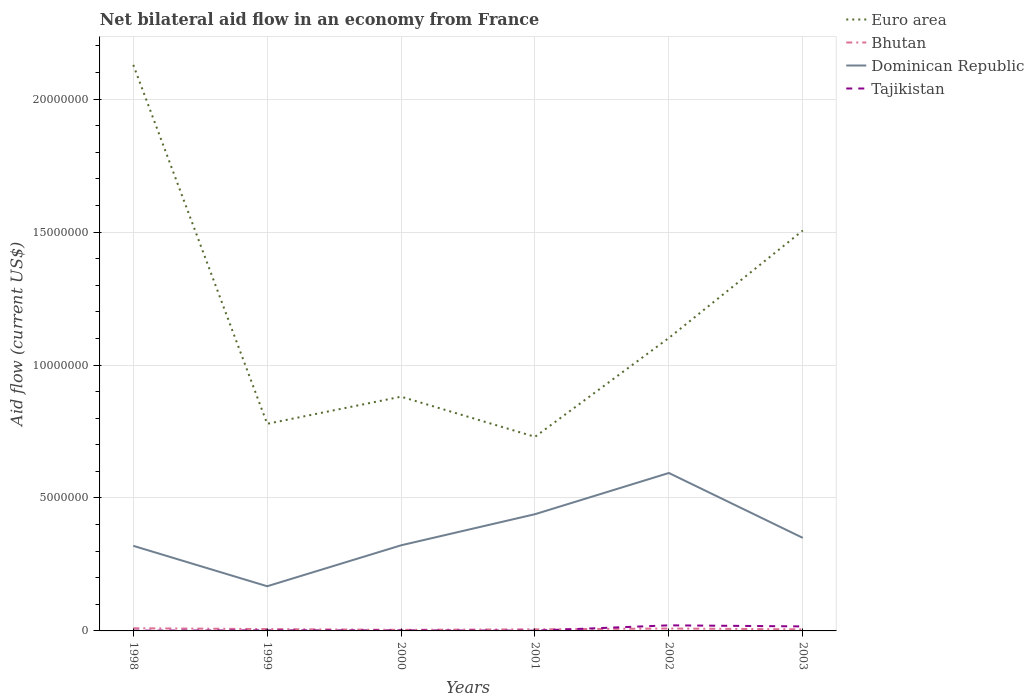How many different coloured lines are there?
Your answer should be very brief. 4. Does the line corresponding to Euro area intersect with the line corresponding to Tajikistan?
Offer a very short reply. No. Is the number of lines equal to the number of legend labels?
Offer a terse response. Yes. Across all years, what is the maximum net bilateral aid flow in Dominican Republic?
Offer a terse response. 1.68e+06. What is the total net bilateral aid flow in Dominican Republic in the graph?
Make the answer very short. -1.17e+06. What is the difference between the highest and the second highest net bilateral aid flow in Euro area?
Make the answer very short. 1.40e+07. How many lines are there?
Make the answer very short. 4. How many years are there in the graph?
Your answer should be very brief. 6. Are the values on the major ticks of Y-axis written in scientific E-notation?
Offer a terse response. No. What is the title of the graph?
Offer a terse response. Net bilateral aid flow in an economy from France. What is the label or title of the Y-axis?
Make the answer very short. Aid flow (current US$). What is the Aid flow (current US$) of Euro area in 1998?
Make the answer very short. 2.13e+07. What is the Aid flow (current US$) in Bhutan in 1998?
Make the answer very short. 1.00e+05. What is the Aid flow (current US$) in Dominican Republic in 1998?
Ensure brevity in your answer.  3.20e+06. What is the Aid flow (current US$) of Tajikistan in 1998?
Keep it short and to the point. 10000. What is the Aid flow (current US$) in Euro area in 1999?
Provide a succinct answer. 7.79e+06. What is the Aid flow (current US$) in Dominican Republic in 1999?
Provide a short and direct response. 1.68e+06. What is the Aid flow (current US$) in Tajikistan in 1999?
Make the answer very short. 2.00e+04. What is the Aid flow (current US$) of Euro area in 2000?
Your response must be concise. 8.81e+06. What is the Aid flow (current US$) of Bhutan in 2000?
Give a very brief answer. 4.00e+04. What is the Aid flow (current US$) in Dominican Republic in 2000?
Your response must be concise. 3.22e+06. What is the Aid flow (current US$) of Tajikistan in 2000?
Offer a very short reply. 2.00e+04. What is the Aid flow (current US$) of Euro area in 2001?
Keep it short and to the point. 7.30e+06. What is the Aid flow (current US$) of Dominican Republic in 2001?
Offer a terse response. 4.39e+06. What is the Aid flow (current US$) of Euro area in 2002?
Your answer should be compact. 1.10e+07. What is the Aid flow (current US$) of Bhutan in 2002?
Provide a succinct answer. 9.00e+04. What is the Aid flow (current US$) of Dominican Republic in 2002?
Your response must be concise. 5.94e+06. What is the Aid flow (current US$) in Euro area in 2003?
Give a very brief answer. 1.51e+07. What is the Aid flow (current US$) in Bhutan in 2003?
Make the answer very short. 6.00e+04. What is the Aid flow (current US$) in Dominican Republic in 2003?
Your answer should be very brief. 3.50e+06. Across all years, what is the maximum Aid flow (current US$) of Euro area?
Give a very brief answer. 2.13e+07. Across all years, what is the maximum Aid flow (current US$) in Bhutan?
Ensure brevity in your answer.  1.00e+05. Across all years, what is the maximum Aid flow (current US$) of Dominican Republic?
Offer a very short reply. 5.94e+06. Across all years, what is the maximum Aid flow (current US$) of Tajikistan?
Offer a very short reply. 2.10e+05. Across all years, what is the minimum Aid flow (current US$) of Euro area?
Provide a short and direct response. 7.30e+06. Across all years, what is the minimum Aid flow (current US$) of Dominican Republic?
Offer a very short reply. 1.68e+06. Across all years, what is the minimum Aid flow (current US$) of Tajikistan?
Provide a succinct answer. 10000. What is the total Aid flow (current US$) in Euro area in the graph?
Keep it short and to the point. 7.13e+07. What is the total Aid flow (current US$) in Bhutan in the graph?
Give a very brief answer. 4.20e+05. What is the total Aid flow (current US$) of Dominican Republic in the graph?
Offer a very short reply. 2.19e+07. What is the total Aid flow (current US$) of Tajikistan in the graph?
Provide a short and direct response. 4.40e+05. What is the difference between the Aid flow (current US$) in Euro area in 1998 and that in 1999?
Ensure brevity in your answer.  1.35e+07. What is the difference between the Aid flow (current US$) of Bhutan in 1998 and that in 1999?
Offer a very short reply. 3.00e+04. What is the difference between the Aid flow (current US$) of Dominican Republic in 1998 and that in 1999?
Your response must be concise. 1.52e+06. What is the difference between the Aid flow (current US$) in Euro area in 1998 and that in 2000?
Provide a short and direct response. 1.25e+07. What is the difference between the Aid flow (current US$) of Tajikistan in 1998 and that in 2000?
Your answer should be very brief. -10000. What is the difference between the Aid flow (current US$) in Euro area in 1998 and that in 2001?
Give a very brief answer. 1.40e+07. What is the difference between the Aid flow (current US$) in Dominican Republic in 1998 and that in 2001?
Your answer should be compact. -1.19e+06. What is the difference between the Aid flow (current US$) of Euro area in 1998 and that in 2002?
Provide a short and direct response. 1.03e+07. What is the difference between the Aid flow (current US$) in Dominican Republic in 1998 and that in 2002?
Keep it short and to the point. -2.74e+06. What is the difference between the Aid flow (current US$) of Euro area in 1998 and that in 2003?
Keep it short and to the point. 6.23e+06. What is the difference between the Aid flow (current US$) of Bhutan in 1998 and that in 2003?
Provide a succinct answer. 4.00e+04. What is the difference between the Aid flow (current US$) of Euro area in 1999 and that in 2000?
Provide a short and direct response. -1.02e+06. What is the difference between the Aid flow (current US$) of Dominican Republic in 1999 and that in 2000?
Keep it short and to the point. -1.54e+06. What is the difference between the Aid flow (current US$) in Bhutan in 1999 and that in 2001?
Offer a terse response. 10000. What is the difference between the Aid flow (current US$) of Dominican Republic in 1999 and that in 2001?
Offer a very short reply. -2.71e+06. What is the difference between the Aid flow (current US$) in Euro area in 1999 and that in 2002?
Provide a succinct answer. -3.23e+06. What is the difference between the Aid flow (current US$) of Bhutan in 1999 and that in 2002?
Your answer should be compact. -2.00e+04. What is the difference between the Aid flow (current US$) of Dominican Republic in 1999 and that in 2002?
Your answer should be very brief. -4.26e+06. What is the difference between the Aid flow (current US$) of Tajikistan in 1999 and that in 2002?
Your answer should be very brief. -1.90e+05. What is the difference between the Aid flow (current US$) of Euro area in 1999 and that in 2003?
Make the answer very short. -7.27e+06. What is the difference between the Aid flow (current US$) in Dominican Republic in 1999 and that in 2003?
Your answer should be compact. -1.82e+06. What is the difference between the Aid flow (current US$) of Tajikistan in 1999 and that in 2003?
Offer a terse response. -1.50e+05. What is the difference between the Aid flow (current US$) in Euro area in 2000 and that in 2001?
Give a very brief answer. 1.51e+06. What is the difference between the Aid flow (current US$) of Dominican Republic in 2000 and that in 2001?
Offer a very short reply. -1.17e+06. What is the difference between the Aid flow (current US$) of Euro area in 2000 and that in 2002?
Make the answer very short. -2.21e+06. What is the difference between the Aid flow (current US$) in Bhutan in 2000 and that in 2002?
Ensure brevity in your answer.  -5.00e+04. What is the difference between the Aid flow (current US$) in Dominican Republic in 2000 and that in 2002?
Keep it short and to the point. -2.72e+06. What is the difference between the Aid flow (current US$) of Euro area in 2000 and that in 2003?
Provide a succinct answer. -6.25e+06. What is the difference between the Aid flow (current US$) of Dominican Republic in 2000 and that in 2003?
Keep it short and to the point. -2.80e+05. What is the difference between the Aid flow (current US$) in Euro area in 2001 and that in 2002?
Your response must be concise. -3.72e+06. What is the difference between the Aid flow (current US$) in Bhutan in 2001 and that in 2002?
Make the answer very short. -3.00e+04. What is the difference between the Aid flow (current US$) of Dominican Republic in 2001 and that in 2002?
Ensure brevity in your answer.  -1.55e+06. What is the difference between the Aid flow (current US$) in Tajikistan in 2001 and that in 2002?
Make the answer very short. -2.00e+05. What is the difference between the Aid flow (current US$) in Euro area in 2001 and that in 2003?
Offer a terse response. -7.76e+06. What is the difference between the Aid flow (current US$) in Dominican Republic in 2001 and that in 2003?
Give a very brief answer. 8.90e+05. What is the difference between the Aid flow (current US$) of Tajikistan in 2001 and that in 2003?
Your answer should be compact. -1.60e+05. What is the difference between the Aid flow (current US$) in Euro area in 2002 and that in 2003?
Ensure brevity in your answer.  -4.04e+06. What is the difference between the Aid flow (current US$) of Bhutan in 2002 and that in 2003?
Keep it short and to the point. 3.00e+04. What is the difference between the Aid flow (current US$) in Dominican Republic in 2002 and that in 2003?
Your answer should be compact. 2.44e+06. What is the difference between the Aid flow (current US$) of Tajikistan in 2002 and that in 2003?
Give a very brief answer. 4.00e+04. What is the difference between the Aid flow (current US$) of Euro area in 1998 and the Aid flow (current US$) of Bhutan in 1999?
Ensure brevity in your answer.  2.12e+07. What is the difference between the Aid flow (current US$) of Euro area in 1998 and the Aid flow (current US$) of Dominican Republic in 1999?
Provide a short and direct response. 1.96e+07. What is the difference between the Aid flow (current US$) in Euro area in 1998 and the Aid flow (current US$) in Tajikistan in 1999?
Provide a succinct answer. 2.13e+07. What is the difference between the Aid flow (current US$) of Bhutan in 1998 and the Aid flow (current US$) of Dominican Republic in 1999?
Your answer should be very brief. -1.58e+06. What is the difference between the Aid flow (current US$) in Dominican Republic in 1998 and the Aid flow (current US$) in Tajikistan in 1999?
Your response must be concise. 3.18e+06. What is the difference between the Aid flow (current US$) of Euro area in 1998 and the Aid flow (current US$) of Bhutan in 2000?
Ensure brevity in your answer.  2.12e+07. What is the difference between the Aid flow (current US$) in Euro area in 1998 and the Aid flow (current US$) in Dominican Republic in 2000?
Your response must be concise. 1.81e+07. What is the difference between the Aid flow (current US$) of Euro area in 1998 and the Aid flow (current US$) of Tajikistan in 2000?
Offer a very short reply. 2.13e+07. What is the difference between the Aid flow (current US$) of Bhutan in 1998 and the Aid flow (current US$) of Dominican Republic in 2000?
Your answer should be compact. -3.12e+06. What is the difference between the Aid flow (current US$) of Dominican Republic in 1998 and the Aid flow (current US$) of Tajikistan in 2000?
Provide a succinct answer. 3.18e+06. What is the difference between the Aid flow (current US$) in Euro area in 1998 and the Aid flow (current US$) in Bhutan in 2001?
Keep it short and to the point. 2.12e+07. What is the difference between the Aid flow (current US$) in Euro area in 1998 and the Aid flow (current US$) in Dominican Republic in 2001?
Your answer should be very brief. 1.69e+07. What is the difference between the Aid flow (current US$) of Euro area in 1998 and the Aid flow (current US$) of Tajikistan in 2001?
Ensure brevity in your answer.  2.13e+07. What is the difference between the Aid flow (current US$) of Bhutan in 1998 and the Aid flow (current US$) of Dominican Republic in 2001?
Your response must be concise. -4.29e+06. What is the difference between the Aid flow (current US$) of Bhutan in 1998 and the Aid flow (current US$) of Tajikistan in 2001?
Your answer should be very brief. 9.00e+04. What is the difference between the Aid flow (current US$) of Dominican Republic in 1998 and the Aid flow (current US$) of Tajikistan in 2001?
Keep it short and to the point. 3.19e+06. What is the difference between the Aid flow (current US$) of Euro area in 1998 and the Aid flow (current US$) of Bhutan in 2002?
Your response must be concise. 2.12e+07. What is the difference between the Aid flow (current US$) of Euro area in 1998 and the Aid flow (current US$) of Dominican Republic in 2002?
Keep it short and to the point. 1.54e+07. What is the difference between the Aid flow (current US$) in Euro area in 1998 and the Aid flow (current US$) in Tajikistan in 2002?
Your response must be concise. 2.11e+07. What is the difference between the Aid flow (current US$) in Bhutan in 1998 and the Aid flow (current US$) in Dominican Republic in 2002?
Your answer should be very brief. -5.84e+06. What is the difference between the Aid flow (current US$) of Bhutan in 1998 and the Aid flow (current US$) of Tajikistan in 2002?
Offer a very short reply. -1.10e+05. What is the difference between the Aid flow (current US$) of Dominican Republic in 1998 and the Aid flow (current US$) of Tajikistan in 2002?
Make the answer very short. 2.99e+06. What is the difference between the Aid flow (current US$) of Euro area in 1998 and the Aid flow (current US$) of Bhutan in 2003?
Offer a terse response. 2.12e+07. What is the difference between the Aid flow (current US$) of Euro area in 1998 and the Aid flow (current US$) of Dominican Republic in 2003?
Your response must be concise. 1.78e+07. What is the difference between the Aid flow (current US$) of Euro area in 1998 and the Aid flow (current US$) of Tajikistan in 2003?
Your response must be concise. 2.11e+07. What is the difference between the Aid flow (current US$) in Bhutan in 1998 and the Aid flow (current US$) in Dominican Republic in 2003?
Make the answer very short. -3.40e+06. What is the difference between the Aid flow (current US$) in Bhutan in 1998 and the Aid flow (current US$) in Tajikistan in 2003?
Give a very brief answer. -7.00e+04. What is the difference between the Aid flow (current US$) of Dominican Republic in 1998 and the Aid flow (current US$) of Tajikistan in 2003?
Your answer should be compact. 3.03e+06. What is the difference between the Aid flow (current US$) in Euro area in 1999 and the Aid flow (current US$) in Bhutan in 2000?
Offer a terse response. 7.75e+06. What is the difference between the Aid flow (current US$) of Euro area in 1999 and the Aid flow (current US$) of Dominican Republic in 2000?
Provide a short and direct response. 4.57e+06. What is the difference between the Aid flow (current US$) of Euro area in 1999 and the Aid flow (current US$) of Tajikistan in 2000?
Your answer should be very brief. 7.77e+06. What is the difference between the Aid flow (current US$) of Bhutan in 1999 and the Aid flow (current US$) of Dominican Republic in 2000?
Offer a terse response. -3.15e+06. What is the difference between the Aid flow (current US$) of Dominican Republic in 1999 and the Aid flow (current US$) of Tajikistan in 2000?
Your answer should be compact. 1.66e+06. What is the difference between the Aid flow (current US$) in Euro area in 1999 and the Aid flow (current US$) in Bhutan in 2001?
Provide a succinct answer. 7.73e+06. What is the difference between the Aid flow (current US$) in Euro area in 1999 and the Aid flow (current US$) in Dominican Republic in 2001?
Make the answer very short. 3.40e+06. What is the difference between the Aid flow (current US$) in Euro area in 1999 and the Aid flow (current US$) in Tajikistan in 2001?
Your answer should be very brief. 7.78e+06. What is the difference between the Aid flow (current US$) of Bhutan in 1999 and the Aid flow (current US$) of Dominican Republic in 2001?
Your response must be concise. -4.32e+06. What is the difference between the Aid flow (current US$) of Bhutan in 1999 and the Aid flow (current US$) of Tajikistan in 2001?
Ensure brevity in your answer.  6.00e+04. What is the difference between the Aid flow (current US$) of Dominican Republic in 1999 and the Aid flow (current US$) of Tajikistan in 2001?
Keep it short and to the point. 1.67e+06. What is the difference between the Aid flow (current US$) of Euro area in 1999 and the Aid flow (current US$) of Bhutan in 2002?
Your response must be concise. 7.70e+06. What is the difference between the Aid flow (current US$) in Euro area in 1999 and the Aid flow (current US$) in Dominican Republic in 2002?
Provide a short and direct response. 1.85e+06. What is the difference between the Aid flow (current US$) of Euro area in 1999 and the Aid flow (current US$) of Tajikistan in 2002?
Provide a short and direct response. 7.58e+06. What is the difference between the Aid flow (current US$) of Bhutan in 1999 and the Aid flow (current US$) of Dominican Republic in 2002?
Offer a very short reply. -5.87e+06. What is the difference between the Aid flow (current US$) in Bhutan in 1999 and the Aid flow (current US$) in Tajikistan in 2002?
Provide a succinct answer. -1.40e+05. What is the difference between the Aid flow (current US$) of Dominican Republic in 1999 and the Aid flow (current US$) of Tajikistan in 2002?
Offer a terse response. 1.47e+06. What is the difference between the Aid flow (current US$) of Euro area in 1999 and the Aid flow (current US$) of Bhutan in 2003?
Ensure brevity in your answer.  7.73e+06. What is the difference between the Aid flow (current US$) in Euro area in 1999 and the Aid flow (current US$) in Dominican Republic in 2003?
Make the answer very short. 4.29e+06. What is the difference between the Aid flow (current US$) in Euro area in 1999 and the Aid flow (current US$) in Tajikistan in 2003?
Make the answer very short. 7.62e+06. What is the difference between the Aid flow (current US$) of Bhutan in 1999 and the Aid flow (current US$) of Dominican Republic in 2003?
Give a very brief answer. -3.43e+06. What is the difference between the Aid flow (current US$) in Bhutan in 1999 and the Aid flow (current US$) in Tajikistan in 2003?
Your answer should be very brief. -1.00e+05. What is the difference between the Aid flow (current US$) in Dominican Republic in 1999 and the Aid flow (current US$) in Tajikistan in 2003?
Ensure brevity in your answer.  1.51e+06. What is the difference between the Aid flow (current US$) of Euro area in 2000 and the Aid flow (current US$) of Bhutan in 2001?
Provide a succinct answer. 8.75e+06. What is the difference between the Aid flow (current US$) of Euro area in 2000 and the Aid flow (current US$) of Dominican Republic in 2001?
Provide a short and direct response. 4.42e+06. What is the difference between the Aid flow (current US$) of Euro area in 2000 and the Aid flow (current US$) of Tajikistan in 2001?
Your answer should be compact. 8.80e+06. What is the difference between the Aid flow (current US$) in Bhutan in 2000 and the Aid flow (current US$) in Dominican Republic in 2001?
Your answer should be very brief. -4.35e+06. What is the difference between the Aid flow (current US$) of Bhutan in 2000 and the Aid flow (current US$) of Tajikistan in 2001?
Keep it short and to the point. 3.00e+04. What is the difference between the Aid flow (current US$) of Dominican Republic in 2000 and the Aid flow (current US$) of Tajikistan in 2001?
Give a very brief answer. 3.21e+06. What is the difference between the Aid flow (current US$) of Euro area in 2000 and the Aid flow (current US$) of Bhutan in 2002?
Your answer should be compact. 8.72e+06. What is the difference between the Aid flow (current US$) in Euro area in 2000 and the Aid flow (current US$) in Dominican Republic in 2002?
Keep it short and to the point. 2.87e+06. What is the difference between the Aid flow (current US$) of Euro area in 2000 and the Aid flow (current US$) of Tajikistan in 2002?
Provide a succinct answer. 8.60e+06. What is the difference between the Aid flow (current US$) of Bhutan in 2000 and the Aid flow (current US$) of Dominican Republic in 2002?
Keep it short and to the point. -5.90e+06. What is the difference between the Aid flow (current US$) of Bhutan in 2000 and the Aid flow (current US$) of Tajikistan in 2002?
Provide a succinct answer. -1.70e+05. What is the difference between the Aid flow (current US$) of Dominican Republic in 2000 and the Aid flow (current US$) of Tajikistan in 2002?
Your answer should be very brief. 3.01e+06. What is the difference between the Aid flow (current US$) in Euro area in 2000 and the Aid flow (current US$) in Bhutan in 2003?
Provide a short and direct response. 8.75e+06. What is the difference between the Aid flow (current US$) of Euro area in 2000 and the Aid flow (current US$) of Dominican Republic in 2003?
Make the answer very short. 5.31e+06. What is the difference between the Aid flow (current US$) in Euro area in 2000 and the Aid flow (current US$) in Tajikistan in 2003?
Offer a very short reply. 8.64e+06. What is the difference between the Aid flow (current US$) of Bhutan in 2000 and the Aid flow (current US$) of Dominican Republic in 2003?
Make the answer very short. -3.46e+06. What is the difference between the Aid flow (current US$) in Bhutan in 2000 and the Aid flow (current US$) in Tajikistan in 2003?
Keep it short and to the point. -1.30e+05. What is the difference between the Aid flow (current US$) of Dominican Republic in 2000 and the Aid flow (current US$) of Tajikistan in 2003?
Your answer should be compact. 3.05e+06. What is the difference between the Aid flow (current US$) in Euro area in 2001 and the Aid flow (current US$) in Bhutan in 2002?
Keep it short and to the point. 7.21e+06. What is the difference between the Aid flow (current US$) of Euro area in 2001 and the Aid flow (current US$) of Dominican Republic in 2002?
Your response must be concise. 1.36e+06. What is the difference between the Aid flow (current US$) in Euro area in 2001 and the Aid flow (current US$) in Tajikistan in 2002?
Your answer should be compact. 7.09e+06. What is the difference between the Aid flow (current US$) of Bhutan in 2001 and the Aid flow (current US$) of Dominican Republic in 2002?
Give a very brief answer. -5.88e+06. What is the difference between the Aid flow (current US$) of Dominican Republic in 2001 and the Aid flow (current US$) of Tajikistan in 2002?
Offer a very short reply. 4.18e+06. What is the difference between the Aid flow (current US$) in Euro area in 2001 and the Aid flow (current US$) in Bhutan in 2003?
Provide a short and direct response. 7.24e+06. What is the difference between the Aid flow (current US$) in Euro area in 2001 and the Aid flow (current US$) in Dominican Republic in 2003?
Your answer should be very brief. 3.80e+06. What is the difference between the Aid flow (current US$) of Euro area in 2001 and the Aid flow (current US$) of Tajikistan in 2003?
Ensure brevity in your answer.  7.13e+06. What is the difference between the Aid flow (current US$) in Bhutan in 2001 and the Aid flow (current US$) in Dominican Republic in 2003?
Keep it short and to the point. -3.44e+06. What is the difference between the Aid flow (current US$) in Bhutan in 2001 and the Aid flow (current US$) in Tajikistan in 2003?
Give a very brief answer. -1.10e+05. What is the difference between the Aid flow (current US$) in Dominican Republic in 2001 and the Aid flow (current US$) in Tajikistan in 2003?
Make the answer very short. 4.22e+06. What is the difference between the Aid flow (current US$) of Euro area in 2002 and the Aid flow (current US$) of Bhutan in 2003?
Your answer should be compact. 1.10e+07. What is the difference between the Aid flow (current US$) of Euro area in 2002 and the Aid flow (current US$) of Dominican Republic in 2003?
Ensure brevity in your answer.  7.52e+06. What is the difference between the Aid flow (current US$) of Euro area in 2002 and the Aid flow (current US$) of Tajikistan in 2003?
Provide a short and direct response. 1.08e+07. What is the difference between the Aid flow (current US$) of Bhutan in 2002 and the Aid flow (current US$) of Dominican Republic in 2003?
Your response must be concise. -3.41e+06. What is the difference between the Aid flow (current US$) of Bhutan in 2002 and the Aid flow (current US$) of Tajikistan in 2003?
Keep it short and to the point. -8.00e+04. What is the difference between the Aid flow (current US$) in Dominican Republic in 2002 and the Aid flow (current US$) in Tajikistan in 2003?
Offer a very short reply. 5.77e+06. What is the average Aid flow (current US$) of Euro area per year?
Make the answer very short. 1.19e+07. What is the average Aid flow (current US$) in Dominican Republic per year?
Make the answer very short. 3.66e+06. What is the average Aid flow (current US$) in Tajikistan per year?
Keep it short and to the point. 7.33e+04. In the year 1998, what is the difference between the Aid flow (current US$) in Euro area and Aid flow (current US$) in Bhutan?
Provide a succinct answer. 2.12e+07. In the year 1998, what is the difference between the Aid flow (current US$) in Euro area and Aid flow (current US$) in Dominican Republic?
Your answer should be very brief. 1.81e+07. In the year 1998, what is the difference between the Aid flow (current US$) of Euro area and Aid flow (current US$) of Tajikistan?
Offer a very short reply. 2.13e+07. In the year 1998, what is the difference between the Aid flow (current US$) in Bhutan and Aid flow (current US$) in Dominican Republic?
Keep it short and to the point. -3.10e+06. In the year 1998, what is the difference between the Aid flow (current US$) in Dominican Republic and Aid flow (current US$) in Tajikistan?
Make the answer very short. 3.19e+06. In the year 1999, what is the difference between the Aid flow (current US$) in Euro area and Aid flow (current US$) in Bhutan?
Offer a very short reply. 7.72e+06. In the year 1999, what is the difference between the Aid flow (current US$) in Euro area and Aid flow (current US$) in Dominican Republic?
Make the answer very short. 6.11e+06. In the year 1999, what is the difference between the Aid flow (current US$) of Euro area and Aid flow (current US$) of Tajikistan?
Make the answer very short. 7.77e+06. In the year 1999, what is the difference between the Aid flow (current US$) in Bhutan and Aid flow (current US$) in Dominican Republic?
Make the answer very short. -1.61e+06. In the year 1999, what is the difference between the Aid flow (current US$) of Dominican Republic and Aid flow (current US$) of Tajikistan?
Provide a short and direct response. 1.66e+06. In the year 2000, what is the difference between the Aid flow (current US$) in Euro area and Aid flow (current US$) in Bhutan?
Give a very brief answer. 8.77e+06. In the year 2000, what is the difference between the Aid flow (current US$) of Euro area and Aid flow (current US$) of Dominican Republic?
Provide a succinct answer. 5.59e+06. In the year 2000, what is the difference between the Aid flow (current US$) in Euro area and Aid flow (current US$) in Tajikistan?
Provide a succinct answer. 8.79e+06. In the year 2000, what is the difference between the Aid flow (current US$) of Bhutan and Aid flow (current US$) of Dominican Republic?
Offer a very short reply. -3.18e+06. In the year 2000, what is the difference between the Aid flow (current US$) of Bhutan and Aid flow (current US$) of Tajikistan?
Your answer should be compact. 2.00e+04. In the year 2000, what is the difference between the Aid flow (current US$) in Dominican Republic and Aid flow (current US$) in Tajikistan?
Offer a terse response. 3.20e+06. In the year 2001, what is the difference between the Aid flow (current US$) in Euro area and Aid flow (current US$) in Bhutan?
Provide a succinct answer. 7.24e+06. In the year 2001, what is the difference between the Aid flow (current US$) of Euro area and Aid flow (current US$) of Dominican Republic?
Keep it short and to the point. 2.91e+06. In the year 2001, what is the difference between the Aid flow (current US$) in Euro area and Aid flow (current US$) in Tajikistan?
Offer a very short reply. 7.29e+06. In the year 2001, what is the difference between the Aid flow (current US$) of Bhutan and Aid flow (current US$) of Dominican Republic?
Ensure brevity in your answer.  -4.33e+06. In the year 2001, what is the difference between the Aid flow (current US$) in Dominican Republic and Aid flow (current US$) in Tajikistan?
Provide a succinct answer. 4.38e+06. In the year 2002, what is the difference between the Aid flow (current US$) in Euro area and Aid flow (current US$) in Bhutan?
Give a very brief answer. 1.09e+07. In the year 2002, what is the difference between the Aid flow (current US$) of Euro area and Aid flow (current US$) of Dominican Republic?
Offer a very short reply. 5.08e+06. In the year 2002, what is the difference between the Aid flow (current US$) of Euro area and Aid flow (current US$) of Tajikistan?
Your answer should be compact. 1.08e+07. In the year 2002, what is the difference between the Aid flow (current US$) in Bhutan and Aid flow (current US$) in Dominican Republic?
Give a very brief answer. -5.85e+06. In the year 2002, what is the difference between the Aid flow (current US$) in Dominican Republic and Aid flow (current US$) in Tajikistan?
Make the answer very short. 5.73e+06. In the year 2003, what is the difference between the Aid flow (current US$) in Euro area and Aid flow (current US$) in Bhutan?
Provide a succinct answer. 1.50e+07. In the year 2003, what is the difference between the Aid flow (current US$) in Euro area and Aid flow (current US$) in Dominican Republic?
Ensure brevity in your answer.  1.16e+07. In the year 2003, what is the difference between the Aid flow (current US$) of Euro area and Aid flow (current US$) of Tajikistan?
Your answer should be very brief. 1.49e+07. In the year 2003, what is the difference between the Aid flow (current US$) of Bhutan and Aid flow (current US$) of Dominican Republic?
Your answer should be compact. -3.44e+06. In the year 2003, what is the difference between the Aid flow (current US$) of Dominican Republic and Aid flow (current US$) of Tajikistan?
Make the answer very short. 3.33e+06. What is the ratio of the Aid flow (current US$) in Euro area in 1998 to that in 1999?
Give a very brief answer. 2.73. What is the ratio of the Aid flow (current US$) of Bhutan in 1998 to that in 1999?
Your answer should be compact. 1.43. What is the ratio of the Aid flow (current US$) in Dominican Republic in 1998 to that in 1999?
Provide a short and direct response. 1.9. What is the ratio of the Aid flow (current US$) of Tajikistan in 1998 to that in 1999?
Your answer should be compact. 0.5. What is the ratio of the Aid flow (current US$) in Euro area in 1998 to that in 2000?
Your response must be concise. 2.42. What is the ratio of the Aid flow (current US$) in Euro area in 1998 to that in 2001?
Your answer should be compact. 2.92. What is the ratio of the Aid flow (current US$) of Dominican Republic in 1998 to that in 2001?
Ensure brevity in your answer.  0.73. What is the ratio of the Aid flow (current US$) in Euro area in 1998 to that in 2002?
Ensure brevity in your answer.  1.93. What is the ratio of the Aid flow (current US$) in Bhutan in 1998 to that in 2002?
Your answer should be very brief. 1.11. What is the ratio of the Aid flow (current US$) of Dominican Republic in 1998 to that in 2002?
Ensure brevity in your answer.  0.54. What is the ratio of the Aid flow (current US$) of Tajikistan in 1998 to that in 2002?
Provide a short and direct response. 0.05. What is the ratio of the Aid flow (current US$) of Euro area in 1998 to that in 2003?
Offer a terse response. 1.41. What is the ratio of the Aid flow (current US$) of Bhutan in 1998 to that in 2003?
Give a very brief answer. 1.67. What is the ratio of the Aid flow (current US$) in Dominican Republic in 1998 to that in 2003?
Your answer should be compact. 0.91. What is the ratio of the Aid flow (current US$) in Tajikistan in 1998 to that in 2003?
Your response must be concise. 0.06. What is the ratio of the Aid flow (current US$) in Euro area in 1999 to that in 2000?
Your response must be concise. 0.88. What is the ratio of the Aid flow (current US$) in Bhutan in 1999 to that in 2000?
Keep it short and to the point. 1.75. What is the ratio of the Aid flow (current US$) of Dominican Republic in 1999 to that in 2000?
Your answer should be compact. 0.52. What is the ratio of the Aid flow (current US$) in Euro area in 1999 to that in 2001?
Your response must be concise. 1.07. What is the ratio of the Aid flow (current US$) of Dominican Republic in 1999 to that in 2001?
Your response must be concise. 0.38. What is the ratio of the Aid flow (current US$) of Tajikistan in 1999 to that in 2001?
Offer a terse response. 2. What is the ratio of the Aid flow (current US$) of Euro area in 1999 to that in 2002?
Keep it short and to the point. 0.71. What is the ratio of the Aid flow (current US$) in Bhutan in 1999 to that in 2002?
Offer a terse response. 0.78. What is the ratio of the Aid flow (current US$) of Dominican Republic in 1999 to that in 2002?
Give a very brief answer. 0.28. What is the ratio of the Aid flow (current US$) of Tajikistan in 1999 to that in 2002?
Provide a succinct answer. 0.1. What is the ratio of the Aid flow (current US$) in Euro area in 1999 to that in 2003?
Ensure brevity in your answer.  0.52. What is the ratio of the Aid flow (current US$) in Bhutan in 1999 to that in 2003?
Provide a succinct answer. 1.17. What is the ratio of the Aid flow (current US$) of Dominican Republic in 1999 to that in 2003?
Your response must be concise. 0.48. What is the ratio of the Aid flow (current US$) in Tajikistan in 1999 to that in 2003?
Give a very brief answer. 0.12. What is the ratio of the Aid flow (current US$) of Euro area in 2000 to that in 2001?
Provide a short and direct response. 1.21. What is the ratio of the Aid flow (current US$) of Bhutan in 2000 to that in 2001?
Your answer should be compact. 0.67. What is the ratio of the Aid flow (current US$) of Dominican Republic in 2000 to that in 2001?
Your response must be concise. 0.73. What is the ratio of the Aid flow (current US$) of Euro area in 2000 to that in 2002?
Offer a very short reply. 0.8. What is the ratio of the Aid flow (current US$) in Bhutan in 2000 to that in 2002?
Offer a very short reply. 0.44. What is the ratio of the Aid flow (current US$) in Dominican Republic in 2000 to that in 2002?
Your answer should be compact. 0.54. What is the ratio of the Aid flow (current US$) in Tajikistan in 2000 to that in 2002?
Your response must be concise. 0.1. What is the ratio of the Aid flow (current US$) in Euro area in 2000 to that in 2003?
Your response must be concise. 0.58. What is the ratio of the Aid flow (current US$) in Dominican Republic in 2000 to that in 2003?
Provide a succinct answer. 0.92. What is the ratio of the Aid flow (current US$) of Tajikistan in 2000 to that in 2003?
Keep it short and to the point. 0.12. What is the ratio of the Aid flow (current US$) of Euro area in 2001 to that in 2002?
Your answer should be very brief. 0.66. What is the ratio of the Aid flow (current US$) of Bhutan in 2001 to that in 2002?
Your response must be concise. 0.67. What is the ratio of the Aid flow (current US$) of Dominican Republic in 2001 to that in 2002?
Keep it short and to the point. 0.74. What is the ratio of the Aid flow (current US$) of Tajikistan in 2001 to that in 2002?
Offer a very short reply. 0.05. What is the ratio of the Aid flow (current US$) of Euro area in 2001 to that in 2003?
Give a very brief answer. 0.48. What is the ratio of the Aid flow (current US$) of Dominican Republic in 2001 to that in 2003?
Your answer should be compact. 1.25. What is the ratio of the Aid flow (current US$) in Tajikistan in 2001 to that in 2003?
Ensure brevity in your answer.  0.06. What is the ratio of the Aid flow (current US$) in Euro area in 2002 to that in 2003?
Give a very brief answer. 0.73. What is the ratio of the Aid flow (current US$) of Bhutan in 2002 to that in 2003?
Provide a succinct answer. 1.5. What is the ratio of the Aid flow (current US$) in Dominican Republic in 2002 to that in 2003?
Your answer should be very brief. 1.7. What is the ratio of the Aid flow (current US$) of Tajikistan in 2002 to that in 2003?
Ensure brevity in your answer.  1.24. What is the difference between the highest and the second highest Aid flow (current US$) of Euro area?
Keep it short and to the point. 6.23e+06. What is the difference between the highest and the second highest Aid flow (current US$) in Bhutan?
Your answer should be very brief. 10000. What is the difference between the highest and the second highest Aid flow (current US$) in Dominican Republic?
Your answer should be compact. 1.55e+06. What is the difference between the highest and the second highest Aid flow (current US$) in Tajikistan?
Your response must be concise. 4.00e+04. What is the difference between the highest and the lowest Aid flow (current US$) in Euro area?
Your response must be concise. 1.40e+07. What is the difference between the highest and the lowest Aid flow (current US$) in Dominican Republic?
Offer a terse response. 4.26e+06. 